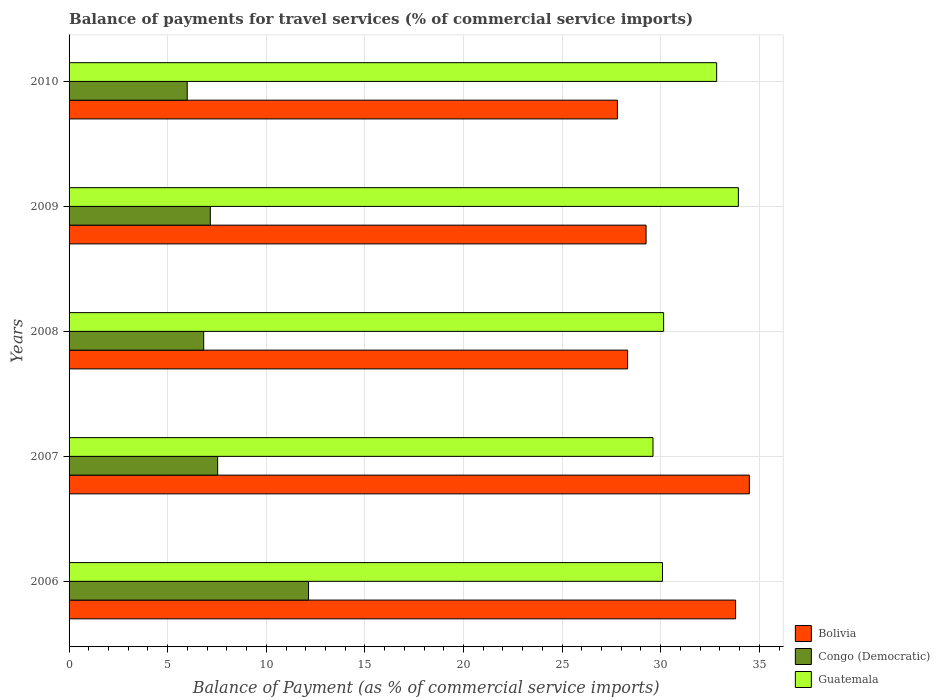How many different coloured bars are there?
Offer a terse response. 3. How many bars are there on the 5th tick from the top?
Your response must be concise. 3. What is the balance of payments for travel services in Bolivia in 2006?
Your answer should be compact. 33.8. Across all years, what is the maximum balance of payments for travel services in Guatemala?
Your answer should be compact. 33.94. Across all years, what is the minimum balance of payments for travel services in Guatemala?
Your response must be concise. 29.61. In which year was the balance of payments for travel services in Congo (Democratic) minimum?
Ensure brevity in your answer.  2010. What is the total balance of payments for travel services in Bolivia in the graph?
Provide a short and direct response. 153.67. What is the difference between the balance of payments for travel services in Guatemala in 2006 and that in 2010?
Offer a very short reply. -2.75. What is the difference between the balance of payments for travel services in Congo (Democratic) in 2009 and the balance of payments for travel services in Guatemala in 2007?
Give a very brief answer. -22.45. What is the average balance of payments for travel services in Guatemala per year?
Offer a very short reply. 31.32. In the year 2009, what is the difference between the balance of payments for travel services in Bolivia and balance of payments for travel services in Congo (Democratic)?
Your response must be concise. 22.1. What is the ratio of the balance of payments for travel services in Guatemala in 2006 to that in 2008?
Your response must be concise. 1. Is the difference between the balance of payments for travel services in Bolivia in 2009 and 2010 greater than the difference between the balance of payments for travel services in Congo (Democratic) in 2009 and 2010?
Keep it short and to the point. Yes. What is the difference between the highest and the second highest balance of payments for travel services in Guatemala?
Keep it short and to the point. 1.1. What is the difference between the highest and the lowest balance of payments for travel services in Congo (Democratic)?
Offer a terse response. 6.15. What does the 1st bar from the top in 2008 represents?
Provide a succinct answer. Guatemala. What does the 2nd bar from the bottom in 2008 represents?
Your response must be concise. Congo (Democratic). How many bars are there?
Keep it short and to the point. 15. Are all the bars in the graph horizontal?
Offer a very short reply. Yes. How many years are there in the graph?
Make the answer very short. 5. Are the values on the major ticks of X-axis written in scientific E-notation?
Offer a terse response. No. Does the graph contain any zero values?
Your answer should be compact. No. How many legend labels are there?
Offer a very short reply. 3. What is the title of the graph?
Offer a terse response. Balance of payments for travel services (% of commercial service imports). Does "Singapore" appear as one of the legend labels in the graph?
Make the answer very short. No. What is the label or title of the X-axis?
Your answer should be compact. Balance of Payment (as % of commercial service imports). What is the label or title of the Y-axis?
Provide a succinct answer. Years. What is the Balance of Payment (as % of commercial service imports) of Bolivia in 2006?
Offer a very short reply. 33.8. What is the Balance of Payment (as % of commercial service imports) of Congo (Democratic) in 2006?
Make the answer very short. 12.14. What is the Balance of Payment (as % of commercial service imports) in Guatemala in 2006?
Provide a succinct answer. 30.09. What is the Balance of Payment (as % of commercial service imports) in Bolivia in 2007?
Offer a terse response. 34.49. What is the Balance of Payment (as % of commercial service imports) of Congo (Democratic) in 2007?
Your answer should be compact. 7.53. What is the Balance of Payment (as % of commercial service imports) in Guatemala in 2007?
Offer a terse response. 29.61. What is the Balance of Payment (as % of commercial service imports) of Bolivia in 2008?
Provide a succinct answer. 28.32. What is the Balance of Payment (as % of commercial service imports) of Congo (Democratic) in 2008?
Your answer should be compact. 6.83. What is the Balance of Payment (as % of commercial service imports) in Guatemala in 2008?
Offer a very short reply. 30.15. What is the Balance of Payment (as % of commercial service imports) of Bolivia in 2009?
Offer a very short reply. 29.26. What is the Balance of Payment (as % of commercial service imports) in Congo (Democratic) in 2009?
Your response must be concise. 7.16. What is the Balance of Payment (as % of commercial service imports) in Guatemala in 2009?
Your response must be concise. 33.94. What is the Balance of Payment (as % of commercial service imports) in Bolivia in 2010?
Offer a very short reply. 27.8. What is the Balance of Payment (as % of commercial service imports) in Congo (Democratic) in 2010?
Provide a short and direct response. 5.99. What is the Balance of Payment (as % of commercial service imports) of Guatemala in 2010?
Provide a succinct answer. 32.84. Across all years, what is the maximum Balance of Payment (as % of commercial service imports) in Bolivia?
Your answer should be very brief. 34.49. Across all years, what is the maximum Balance of Payment (as % of commercial service imports) in Congo (Democratic)?
Provide a succinct answer. 12.14. Across all years, what is the maximum Balance of Payment (as % of commercial service imports) in Guatemala?
Offer a terse response. 33.94. Across all years, what is the minimum Balance of Payment (as % of commercial service imports) of Bolivia?
Make the answer very short. 27.8. Across all years, what is the minimum Balance of Payment (as % of commercial service imports) in Congo (Democratic)?
Keep it short and to the point. 5.99. Across all years, what is the minimum Balance of Payment (as % of commercial service imports) in Guatemala?
Your response must be concise. 29.61. What is the total Balance of Payment (as % of commercial service imports) in Bolivia in the graph?
Your response must be concise. 153.67. What is the total Balance of Payment (as % of commercial service imports) in Congo (Democratic) in the graph?
Offer a terse response. 39.66. What is the total Balance of Payment (as % of commercial service imports) in Guatemala in the graph?
Ensure brevity in your answer.  156.62. What is the difference between the Balance of Payment (as % of commercial service imports) in Bolivia in 2006 and that in 2007?
Offer a very short reply. -0.7. What is the difference between the Balance of Payment (as % of commercial service imports) of Congo (Democratic) in 2006 and that in 2007?
Your response must be concise. 4.61. What is the difference between the Balance of Payment (as % of commercial service imports) of Guatemala in 2006 and that in 2007?
Offer a very short reply. 0.48. What is the difference between the Balance of Payment (as % of commercial service imports) of Bolivia in 2006 and that in 2008?
Your answer should be compact. 5.48. What is the difference between the Balance of Payment (as % of commercial service imports) in Congo (Democratic) in 2006 and that in 2008?
Offer a terse response. 5.32. What is the difference between the Balance of Payment (as % of commercial service imports) of Guatemala in 2006 and that in 2008?
Your response must be concise. -0.06. What is the difference between the Balance of Payment (as % of commercial service imports) of Bolivia in 2006 and that in 2009?
Offer a very short reply. 4.54. What is the difference between the Balance of Payment (as % of commercial service imports) of Congo (Democratic) in 2006 and that in 2009?
Give a very brief answer. 4.98. What is the difference between the Balance of Payment (as % of commercial service imports) of Guatemala in 2006 and that in 2009?
Provide a succinct answer. -3.85. What is the difference between the Balance of Payment (as % of commercial service imports) of Bolivia in 2006 and that in 2010?
Your answer should be very brief. 5.99. What is the difference between the Balance of Payment (as % of commercial service imports) in Congo (Democratic) in 2006 and that in 2010?
Your answer should be very brief. 6.15. What is the difference between the Balance of Payment (as % of commercial service imports) in Guatemala in 2006 and that in 2010?
Your answer should be very brief. -2.75. What is the difference between the Balance of Payment (as % of commercial service imports) of Bolivia in 2007 and that in 2008?
Ensure brevity in your answer.  6.17. What is the difference between the Balance of Payment (as % of commercial service imports) in Congo (Democratic) in 2007 and that in 2008?
Make the answer very short. 0.71. What is the difference between the Balance of Payment (as % of commercial service imports) in Guatemala in 2007 and that in 2008?
Your response must be concise. -0.54. What is the difference between the Balance of Payment (as % of commercial service imports) of Bolivia in 2007 and that in 2009?
Give a very brief answer. 5.24. What is the difference between the Balance of Payment (as % of commercial service imports) of Congo (Democratic) in 2007 and that in 2009?
Provide a short and direct response. 0.37. What is the difference between the Balance of Payment (as % of commercial service imports) in Guatemala in 2007 and that in 2009?
Offer a very short reply. -4.33. What is the difference between the Balance of Payment (as % of commercial service imports) of Bolivia in 2007 and that in 2010?
Offer a terse response. 6.69. What is the difference between the Balance of Payment (as % of commercial service imports) of Congo (Democratic) in 2007 and that in 2010?
Provide a succinct answer. 1.54. What is the difference between the Balance of Payment (as % of commercial service imports) in Guatemala in 2007 and that in 2010?
Offer a very short reply. -3.23. What is the difference between the Balance of Payment (as % of commercial service imports) in Bolivia in 2008 and that in 2009?
Your answer should be compact. -0.94. What is the difference between the Balance of Payment (as % of commercial service imports) of Congo (Democratic) in 2008 and that in 2009?
Provide a succinct answer. -0.34. What is the difference between the Balance of Payment (as % of commercial service imports) of Guatemala in 2008 and that in 2009?
Ensure brevity in your answer.  -3.79. What is the difference between the Balance of Payment (as % of commercial service imports) in Bolivia in 2008 and that in 2010?
Give a very brief answer. 0.52. What is the difference between the Balance of Payment (as % of commercial service imports) of Congo (Democratic) in 2008 and that in 2010?
Provide a succinct answer. 0.84. What is the difference between the Balance of Payment (as % of commercial service imports) in Guatemala in 2008 and that in 2010?
Make the answer very short. -2.69. What is the difference between the Balance of Payment (as % of commercial service imports) of Bolivia in 2009 and that in 2010?
Keep it short and to the point. 1.45. What is the difference between the Balance of Payment (as % of commercial service imports) in Congo (Democratic) in 2009 and that in 2010?
Provide a short and direct response. 1.17. What is the difference between the Balance of Payment (as % of commercial service imports) in Guatemala in 2009 and that in 2010?
Provide a short and direct response. 1.1. What is the difference between the Balance of Payment (as % of commercial service imports) of Bolivia in 2006 and the Balance of Payment (as % of commercial service imports) of Congo (Democratic) in 2007?
Keep it short and to the point. 26.26. What is the difference between the Balance of Payment (as % of commercial service imports) in Bolivia in 2006 and the Balance of Payment (as % of commercial service imports) in Guatemala in 2007?
Offer a terse response. 4.19. What is the difference between the Balance of Payment (as % of commercial service imports) in Congo (Democratic) in 2006 and the Balance of Payment (as % of commercial service imports) in Guatemala in 2007?
Your response must be concise. -17.47. What is the difference between the Balance of Payment (as % of commercial service imports) in Bolivia in 2006 and the Balance of Payment (as % of commercial service imports) in Congo (Democratic) in 2008?
Offer a very short reply. 26.97. What is the difference between the Balance of Payment (as % of commercial service imports) in Bolivia in 2006 and the Balance of Payment (as % of commercial service imports) in Guatemala in 2008?
Offer a terse response. 3.65. What is the difference between the Balance of Payment (as % of commercial service imports) in Congo (Democratic) in 2006 and the Balance of Payment (as % of commercial service imports) in Guatemala in 2008?
Give a very brief answer. -18. What is the difference between the Balance of Payment (as % of commercial service imports) in Bolivia in 2006 and the Balance of Payment (as % of commercial service imports) in Congo (Democratic) in 2009?
Provide a succinct answer. 26.64. What is the difference between the Balance of Payment (as % of commercial service imports) in Bolivia in 2006 and the Balance of Payment (as % of commercial service imports) in Guatemala in 2009?
Give a very brief answer. -0.14. What is the difference between the Balance of Payment (as % of commercial service imports) of Congo (Democratic) in 2006 and the Balance of Payment (as % of commercial service imports) of Guatemala in 2009?
Keep it short and to the point. -21.8. What is the difference between the Balance of Payment (as % of commercial service imports) in Bolivia in 2006 and the Balance of Payment (as % of commercial service imports) in Congo (Democratic) in 2010?
Your response must be concise. 27.81. What is the difference between the Balance of Payment (as % of commercial service imports) in Bolivia in 2006 and the Balance of Payment (as % of commercial service imports) in Guatemala in 2010?
Your response must be concise. 0.96. What is the difference between the Balance of Payment (as % of commercial service imports) in Congo (Democratic) in 2006 and the Balance of Payment (as % of commercial service imports) in Guatemala in 2010?
Provide a succinct answer. -20.69. What is the difference between the Balance of Payment (as % of commercial service imports) of Bolivia in 2007 and the Balance of Payment (as % of commercial service imports) of Congo (Democratic) in 2008?
Your answer should be compact. 27.67. What is the difference between the Balance of Payment (as % of commercial service imports) of Bolivia in 2007 and the Balance of Payment (as % of commercial service imports) of Guatemala in 2008?
Provide a succinct answer. 4.35. What is the difference between the Balance of Payment (as % of commercial service imports) in Congo (Democratic) in 2007 and the Balance of Payment (as % of commercial service imports) in Guatemala in 2008?
Your answer should be very brief. -22.61. What is the difference between the Balance of Payment (as % of commercial service imports) in Bolivia in 2007 and the Balance of Payment (as % of commercial service imports) in Congo (Democratic) in 2009?
Offer a very short reply. 27.33. What is the difference between the Balance of Payment (as % of commercial service imports) of Bolivia in 2007 and the Balance of Payment (as % of commercial service imports) of Guatemala in 2009?
Your response must be concise. 0.55. What is the difference between the Balance of Payment (as % of commercial service imports) of Congo (Democratic) in 2007 and the Balance of Payment (as % of commercial service imports) of Guatemala in 2009?
Offer a terse response. -26.4. What is the difference between the Balance of Payment (as % of commercial service imports) of Bolivia in 2007 and the Balance of Payment (as % of commercial service imports) of Congo (Democratic) in 2010?
Your response must be concise. 28.5. What is the difference between the Balance of Payment (as % of commercial service imports) in Bolivia in 2007 and the Balance of Payment (as % of commercial service imports) in Guatemala in 2010?
Keep it short and to the point. 1.66. What is the difference between the Balance of Payment (as % of commercial service imports) of Congo (Democratic) in 2007 and the Balance of Payment (as % of commercial service imports) of Guatemala in 2010?
Ensure brevity in your answer.  -25.3. What is the difference between the Balance of Payment (as % of commercial service imports) in Bolivia in 2008 and the Balance of Payment (as % of commercial service imports) in Congo (Democratic) in 2009?
Provide a short and direct response. 21.16. What is the difference between the Balance of Payment (as % of commercial service imports) in Bolivia in 2008 and the Balance of Payment (as % of commercial service imports) in Guatemala in 2009?
Offer a terse response. -5.62. What is the difference between the Balance of Payment (as % of commercial service imports) of Congo (Democratic) in 2008 and the Balance of Payment (as % of commercial service imports) of Guatemala in 2009?
Your answer should be compact. -27.11. What is the difference between the Balance of Payment (as % of commercial service imports) of Bolivia in 2008 and the Balance of Payment (as % of commercial service imports) of Congo (Democratic) in 2010?
Your answer should be very brief. 22.33. What is the difference between the Balance of Payment (as % of commercial service imports) in Bolivia in 2008 and the Balance of Payment (as % of commercial service imports) in Guatemala in 2010?
Keep it short and to the point. -4.52. What is the difference between the Balance of Payment (as % of commercial service imports) of Congo (Democratic) in 2008 and the Balance of Payment (as % of commercial service imports) of Guatemala in 2010?
Your answer should be very brief. -26.01. What is the difference between the Balance of Payment (as % of commercial service imports) in Bolivia in 2009 and the Balance of Payment (as % of commercial service imports) in Congo (Democratic) in 2010?
Offer a terse response. 23.27. What is the difference between the Balance of Payment (as % of commercial service imports) of Bolivia in 2009 and the Balance of Payment (as % of commercial service imports) of Guatemala in 2010?
Provide a short and direct response. -3.58. What is the difference between the Balance of Payment (as % of commercial service imports) in Congo (Democratic) in 2009 and the Balance of Payment (as % of commercial service imports) in Guatemala in 2010?
Your response must be concise. -25.68. What is the average Balance of Payment (as % of commercial service imports) of Bolivia per year?
Ensure brevity in your answer.  30.73. What is the average Balance of Payment (as % of commercial service imports) in Congo (Democratic) per year?
Ensure brevity in your answer.  7.93. What is the average Balance of Payment (as % of commercial service imports) in Guatemala per year?
Provide a succinct answer. 31.32. In the year 2006, what is the difference between the Balance of Payment (as % of commercial service imports) of Bolivia and Balance of Payment (as % of commercial service imports) of Congo (Democratic)?
Your answer should be very brief. 21.65. In the year 2006, what is the difference between the Balance of Payment (as % of commercial service imports) in Bolivia and Balance of Payment (as % of commercial service imports) in Guatemala?
Your answer should be compact. 3.71. In the year 2006, what is the difference between the Balance of Payment (as % of commercial service imports) in Congo (Democratic) and Balance of Payment (as % of commercial service imports) in Guatemala?
Your answer should be compact. -17.95. In the year 2007, what is the difference between the Balance of Payment (as % of commercial service imports) in Bolivia and Balance of Payment (as % of commercial service imports) in Congo (Democratic)?
Your response must be concise. 26.96. In the year 2007, what is the difference between the Balance of Payment (as % of commercial service imports) in Bolivia and Balance of Payment (as % of commercial service imports) in Guatemala?
Make the answer very short. 4.88. In the year 2007, what is the difference between the Balance of Payment (as % of commercial service imports) of Congo (Democratic) and Balance of Payment (as % of commercial service imports) of Guatemala?
Provide a succinct answer. -22.07. In the year 2008, what is the difference between the Balance of Payment (as % of commercial service imports) of Bolivia and Balance of Payment (as % of commercial service imports) of Congo (Democratic)?
Ensure brevity in your answer.  21.49. In the year 2008, what is the difference between the Balance of Payment (as % of commercial service imports) in Bolivia and Balance of Payment (as % of commercial service imports) in Guatemala?
Provide a short and direct response. -1.83. In the year 2008, what is the difference between the Balance of Payment (as % of commercial service imports) of Congo (Democratic) and Balance of Payment (as % of commercial service imports) of Guatemala?
Offer a terse response. -23.32. In the year 2009, what is the difference between the Balance of Payment (as % of commercial service imports) in Bolivia and Balance of Payment (as % of commercial service imports) in Congo (Democratic)?
Provide a short and direct response. 22.1. In the year 2009, what is the difference between the Balance of Payment (as % of commercial service imports) of Bolivia and Balance of Payment (as % of commercial service imports) of Guatemala?
Provide a short and direct response. -4.68. In the year 2009, what is the difference between the Balance of Payment (as % of commercial service imports) of Congo (Democratic) and Balance of Payment (as % of commercial service imports) of Guatemala?
Your response must be concise. -26.78. In the year 2010, what is the difference between the Balance of Payment (as % of commercial service imports) of Bolivia and Balance of Payment (as % of commercial service imports) of Congo (Democratic)?
Keep it short and to the point. 21.81. In the year 2010, what is the difference between the Balance of Payment (as % of commercial service imports) of Bolivia and Balance of Payment (as % of commercial service imports) of Guatemala?
Your answer should be very brief. -5.03. In the year 2010, what is the difference between the Balance of Payment (as % of commercial service imports) of Congo (Democratic) and Balance of Payment (as % of commercial service imports) of Guatemala?
Offer a very short reply. -26.85. What is the ratio of the Balance of Payment (as % of commercial service imports) in Bolivia in 2006 to that in 2007?
Offer a terse response. 0.98. What is the ratio of the Balance of Payment (as % of commercial service imports) of Congo (Democratic) in 2006 to that in 2007?
Your answer should be very brief. 1.61. What is the ratio of the Balance of Payment (as % of commercial service imports) of Guatemala in 2006 to that in 2007?
Your answer should be very brief. 1.02. What is the ratio of the Balance of Payment (as % of commercial service imports) in Bolivia in 2006 to that in 2008?
Offer a very short reply. 1.19. What is the ratio of the Balance of Payment (as % of commercial service imports) in Congo (Democratic) in 2006 to that in 2008?
Provide a succinct answer. 1.78. What is the ratio of the Balance of Payment (as % of commercial service imports) in Bolivia in 2006 to that in 2009?
Offer a terse response. 1.16. What is the ratio of the Balance of Payment (as % of commercial service imports) in Congo (Democratic) in 2006 to that in 2009?
Give a very brief answer. 1.7. What is the ratio of the Balance of Payment (as % of commercial service imports) of Guatemala in 2006 to that in 2009?
Give a very brief answer. 0.89. What is the ratio of the Balance of Payment (as % of commercial service imports) in Bolivia in 2006 to that in 2010?
Give a very brief answer. 1.22. What is the ratio of the Balance of Payment (as % of commercial service imports) of Congo (Democratic) in 2006 to that in 2010?
Give a very brief answer. 2.03. What is the ratio of the Balance of Payment (as % of commercial service imports) in Guatemala in 2006 to that in 2010?
Offer a very short reply. 0.92. What is the ratio of the Balance of Payment (as % of commercial service imports) in Bolivia in 2007 to that in 2008?
Make the answer very short. 1.22. What is the ratio of the Balance of Payment (as % of commercial service imports) of Congo (Democratic) in 2007 to that in 2008?
Ensure brevity in your answer.  1.1. What is the ratio of the Balance of Payment (as % of commercial service imports) of Guatemala in 2007 to that in 2008?
Provide a short and direct response. 0.98. What is the ratio of the Balance of Payment (as % of commercial service imports) in Bolivia in 2007 to that in 2009?
Provide a succinct answer. 1.18. What is the ratio of the Balance of Payment (as % of commercial service imports) in Congo (Democratic) in 2007 to that in 2009?
Your response must be concise. 1.05. What is the ratio of the Balance of Payment (as % of commercial service imports) of Guatemala in 2007 to that in 2009?
Make the answer very short. 0.87. What is the ratio of the Balance of Payment (as % of commercial service imports) of Bolivia in 2007 to that in 2010?
Make the answer very short. 1.24. What is the ratio of the Balance of Payment (as % of commercial service imports) of Congo (Democratic) in 2007 to that in 2010?
Your answer should be very brief. 1.26. What is the ratio of the Balance of Payment (as % of commercial service imports) in Guatemala in 2007 to that in 2010?
Your answer should be compact. 0.9. What is the ratio of the Balance of Payment (as % of commercial service imports) of Bolivia in 2008 to that in 2009?
Offer a terse response. 0.97. What is the ratio of the Balance of Payment (as % of commercial service imports) in Congo (Democratic) in 2008 to that in 2009?
Provide a short and direct response. 0.95. What is the ratio of the Balance of Payment (as % of commercial service imports) in Guatemala in 2008 to that in 2009?
Keep it short and to the point. 0.89. What is the ratio of the Balance of Payment (as % of commercial service imports) in Bolivia in 2008 to that in 2010?
Offer a very short reply. 1.02. What is the ratio of the Balance of Payment (as % of commercial service imports) of Congo (Democratic) in 2008 to that in 2010?
Make the answer very short. 1.14. What is the ratio of the Balance of Payment (as % of commercial service imports) in Guatemala in 2008 to that in 2010?
Ensure brevity in your answer.  0.92. What is the ratio of the Balance of Payment (as % of commercial service imports) in Bolivia in 2009 to that in 2010?
Offer a very short reply. 1.05. What is the ratio of the Balance of Payment (as % of commercial service imports) in Congo (Democratic) in 2009 to that in 2010?
Make the answer very short. 1.2. What is the ratio of the Balance of Payment (as % of commercial service imports) in Guatemala in 2009 to that in 2010?
Give a very brief answer. 1.03. What is the difference between the highest and the second highest Balance of Payment (as % of commercial service imports) of Bolivia?
Provide a succinct answer. 0.7. What is the difference between the highest and the second highest Balance of Payment (as % of commercial service imports) of Congo (Democratic)?
Ensure brevity in your answer.  4.61. What is the difference between the highest and the second highest Balance of Payment (as % of commercial service imports) of Guatemala?
Your answer should be compact. 1.1. What is the difference between the highest and the lowest Balance of Payment (as % of commercial service imports) in Bolivia?
Your answer should be compact. 6.69. What is the difference between the highest and the lowest Balance of Payment (as % of commercial service imports) in Congo (Democratic)?
Ensure brevity in your answer.  6.15. What is the difference between the highest and the lowest Balance of Payment (as % of commercial service imports) in Guatemala?
Your answer should be very brief. 4.33. 